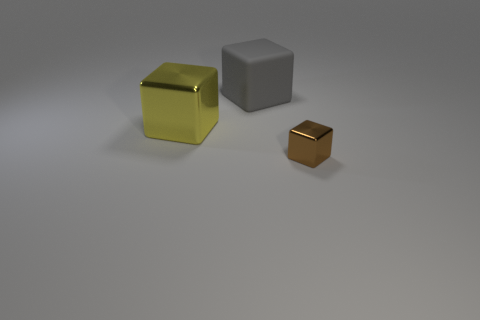Add 3 large purple matte cylinders. How many objects exist? 6 Subtract 0 purple balls. How many objects are left? 3 Subtract all gray matte cubes. Subtract all big matte blocks. How many objects are left? 1 Add 1 tiny brown metal blocks. How many tiny brown metal blocks are left? 2 Add 3 rubber blocks. How many rubber blocks exist? 4 